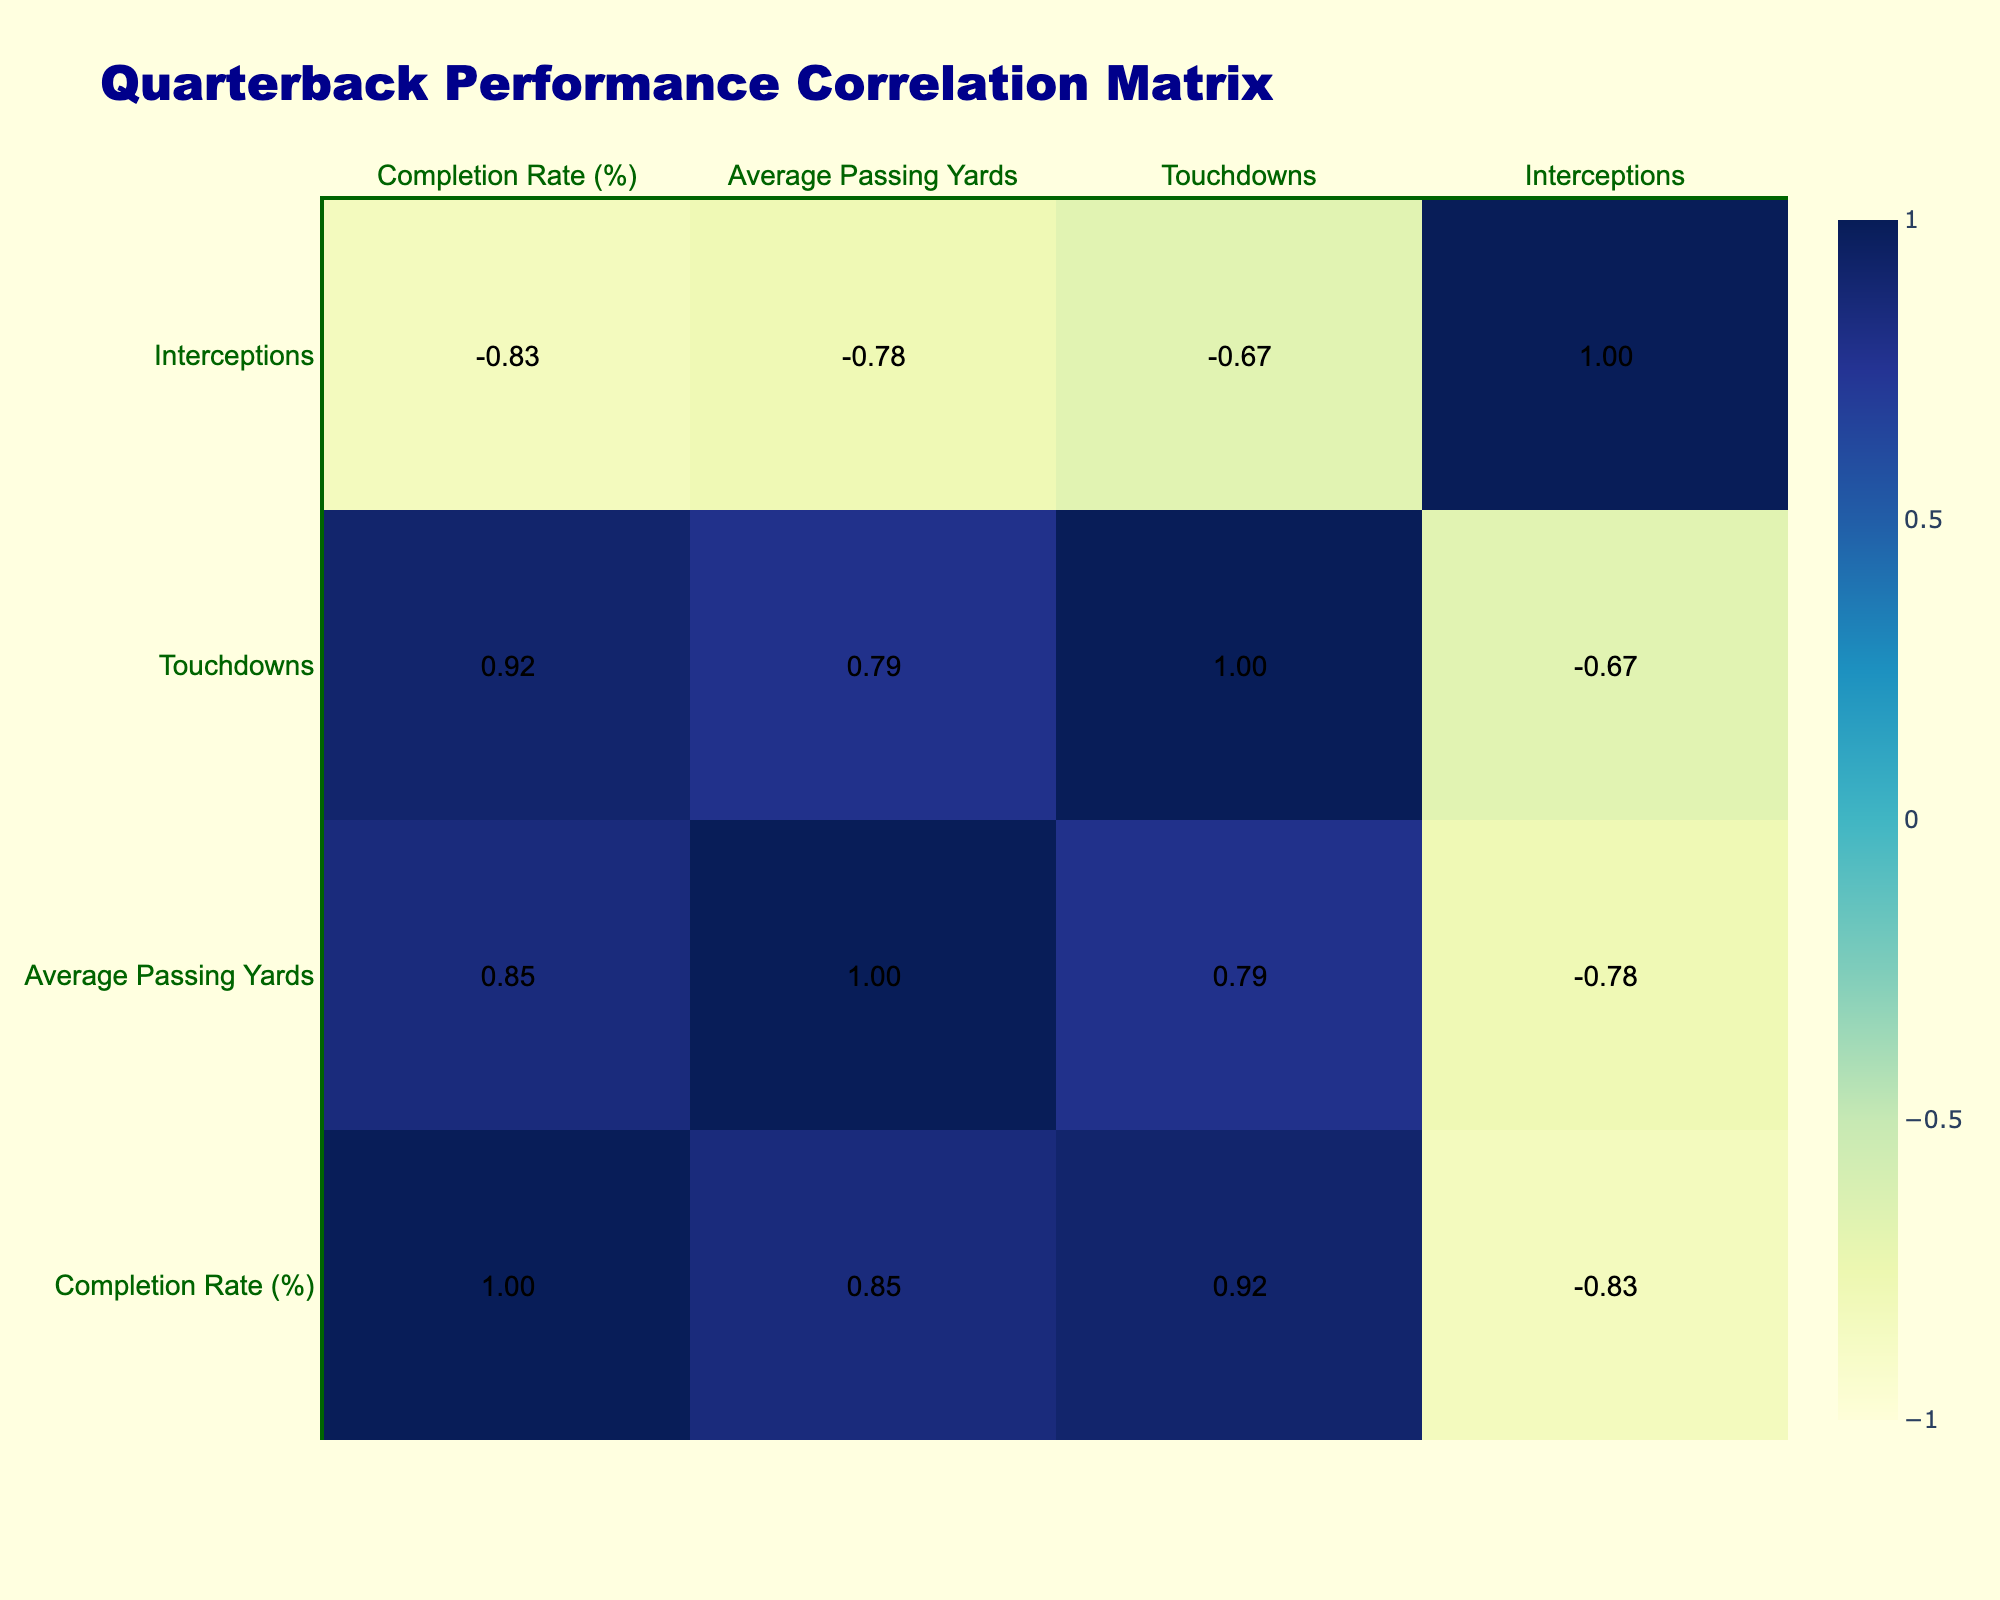What quarterback has the highest completion rate? By reviewing the completion rates of all quarterbacks in the table, I find that Dak Prescott has the highest completion rate of 75%.
Answer: 75% Which quarterback had the most touchdowns in overcast weather? Among the quarterbacks in overcast weather, I see that Matthew Stafford had 2 touchdowns. Therefore, the answer is Matthew Stafford with 2 touchdowns.
Answer: Matthew Stafford with 2 touchdowns What is the average passing yards for quarterbacks who played in snowy conditions? The quarterbacks who played in snowy conditions are Josh Allen, Kyler Murray, and Jalen Hurts with passing yards of 280, 240, and 230 respectively. The total is 280 + 240 + 230 = 750, and dividing by 3 gives an average of 250 yards.
Answer: 250 Did Drew Brees have more touchdowns than Tom Brady? Looking at the touchdowns column, Drew Brees had 3 touchdowns, while Tom Brady had 2 touchdowns. Hence, yes, Drew Brees had more touchdowns than Tom Brady.
Answer: Yes What is the difference in completion rates between quarterbacks in snowy versus rainier conditions? The completion rates for quarterbacks in snowy conditions (Josh Allen 60%, Kyler Murray 55%, Jalen Hurts 58%) average to (60 + 55 + 58) / 3 = 57.67%. In rainy conditions, the completion rates are (65, 63, 60, 61) which averages to (65 + 63 + 60 + 61) / 4 = 62.25%. The difference is 62.25 - 57.67 ≈ 4.58.
Answer: About 4.58 Which quarterback had the highest number of interceptions and in what weather condition did he play? I need to check the interceptions column; I see that Kyler Murray had the highest number of interceptions with 3, while playing in snowy conditions.
Answer: Kyler Murray in snowy conditions 